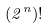Convert formula to latex. <formula><loc_0><loc_0><loc_500><loc_500>( 2 ^ { n } ) !</formula> 